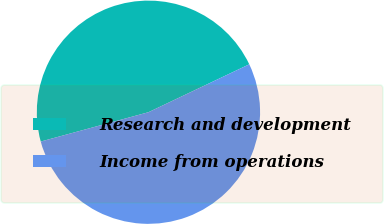<chart> <loc_0><loc_0><loc_500><loc_500><pie_chart><fcel>Research and development<fcel>Income from operations<nl><fcel>47.17%<fcel>52.83%<nl></chart> 